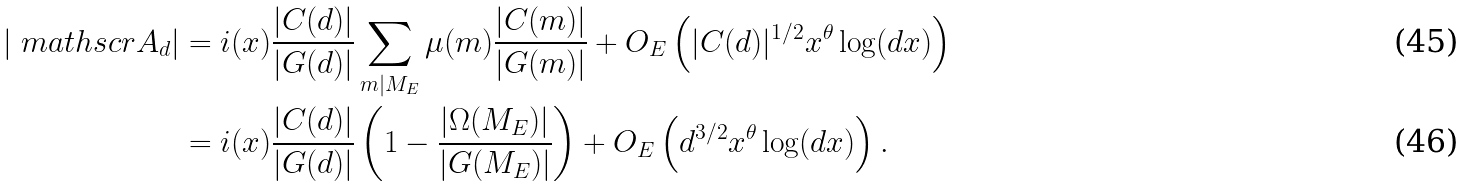<formula> <loc_0><loc_0><loc_500><loc_500>\left | \ m a t h s c r { A } _ { d } \right | & = \L i ( x ) \frac { | C ( d ) | } { | G ( d ) | } \sum _ { m | M _ { E } } \mu ( m ) \frac { | C ( m ) | } { | G ( m ) | } + O _ { E } \left ( | C ( d ) | ^ { 1 / 2 } x ^ { \theta } \log ( d x ) \right ) \\ & = \L i ( x ) \frac { | C ( d ) | } { | G ( d ) | } \left ( 1 - \frac { | \Omega ( M _ { E } ) | } { | G ( M _ { E } ) | } \right ) + O _ { E } \left ( d ^ { 3 / 2 } x ^ { \theta } \log ( d x ) \right ) .</formula> 